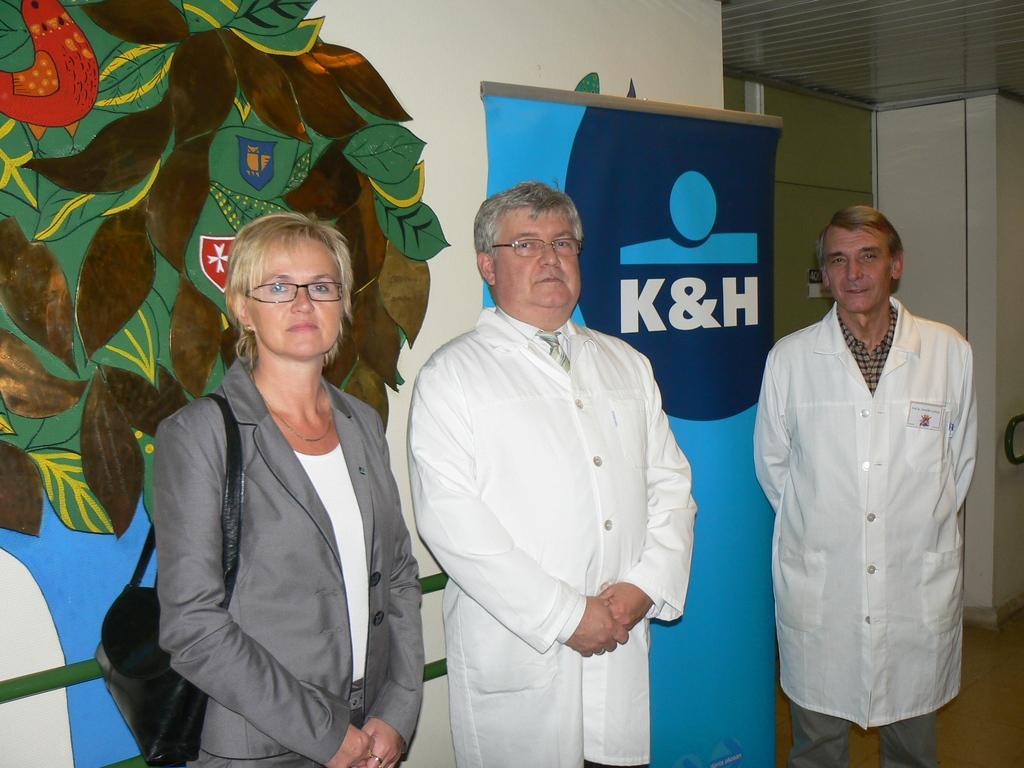Please provide a concise description of this image. In this picture, we can see a few people, and we can see the wall with poster and some text on it, and art, doors, and we can see the roof. 